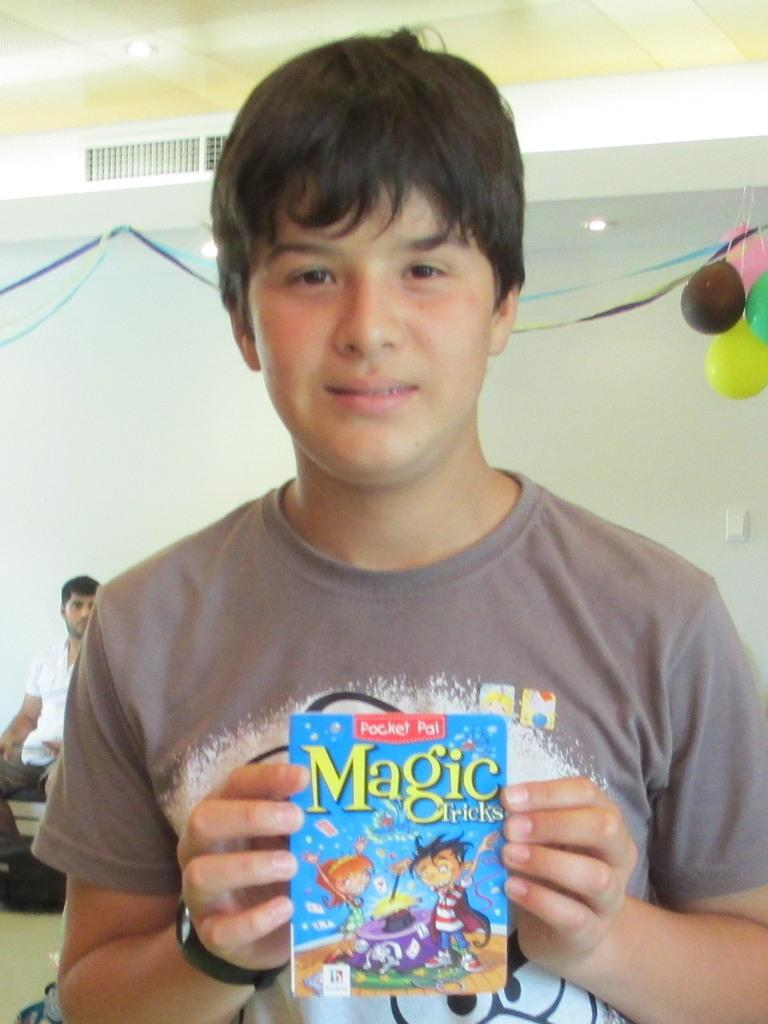What is the man in the foreground of the image holding? The man is holding an object in the image. Can you describe the other man in the image? There is another man sitting in the background of the image. What decorations are present in the image? Balloons are present in the image. What can be seen in the background of the image? There is a wall and lights on the ceiling visible in the image. What type of window can be seen in the image? There is no window present in the image. How much payment is required for the services provided in the image? There is no indication of payment or services in the image. 